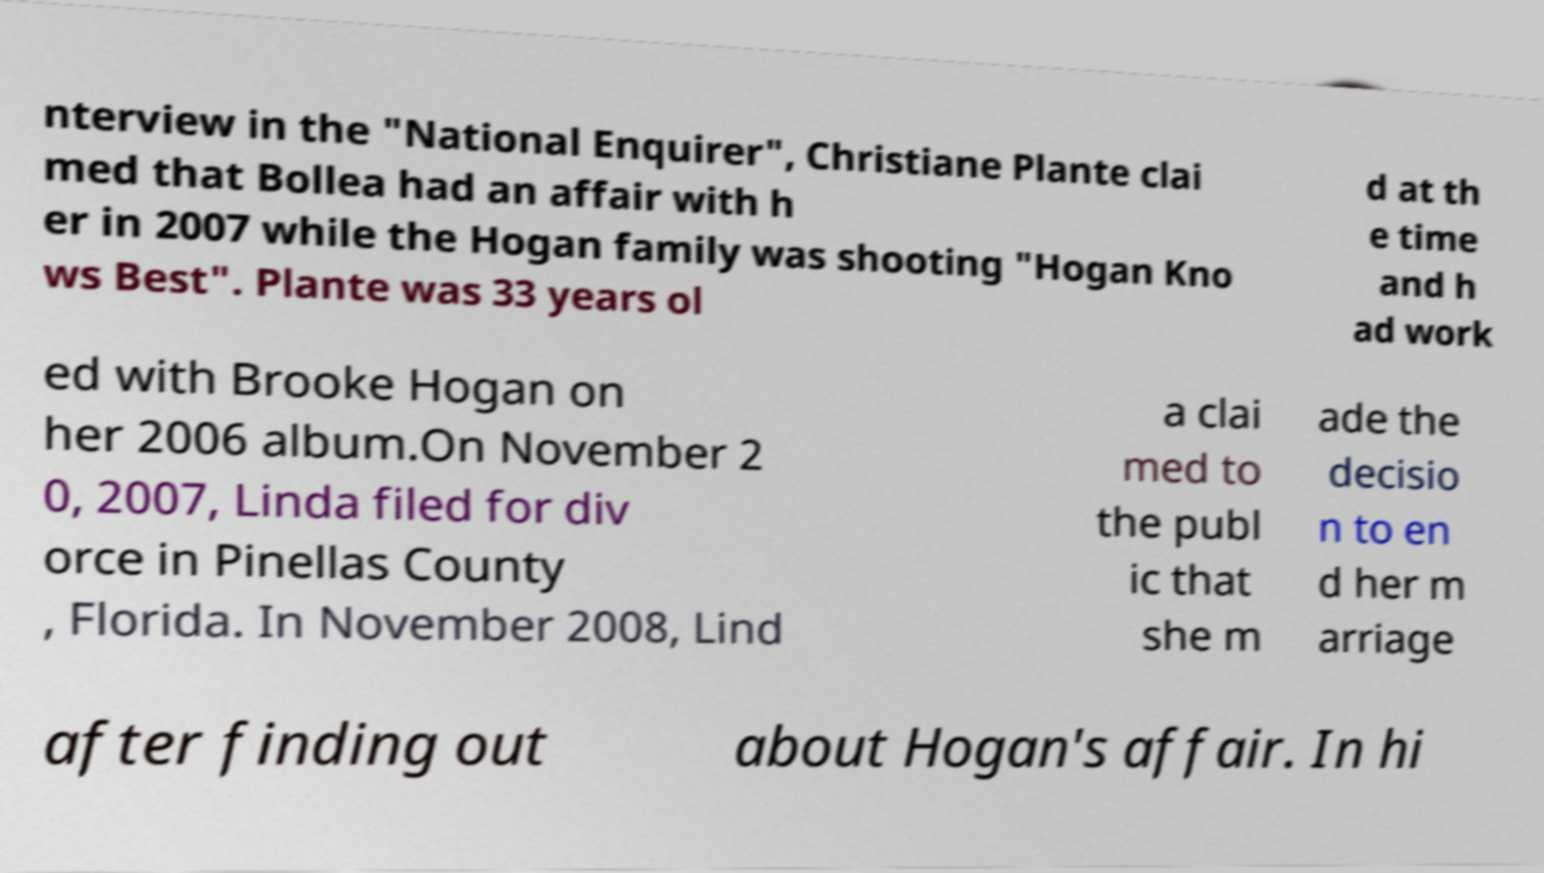Please read and relay the text visible in this image. What does it say? nterview in the "National Enquirer", Christiane Plante clai med that Bollea had an affair with h er in 2007 while the Hogan family was shooting "Hogan Kno ws Best". Plante was 33 years ol d at th e time and h ad work ed with Brooke Hogan on her 2006 album.On November 2 0, 2007, Linda filed for div orce in Pinellas County , Florida. In November 2008, Lind a clai med to the publ ic that she m ade the decisio n to en d her m arriage after finding out about Hogan's affair. In hi 